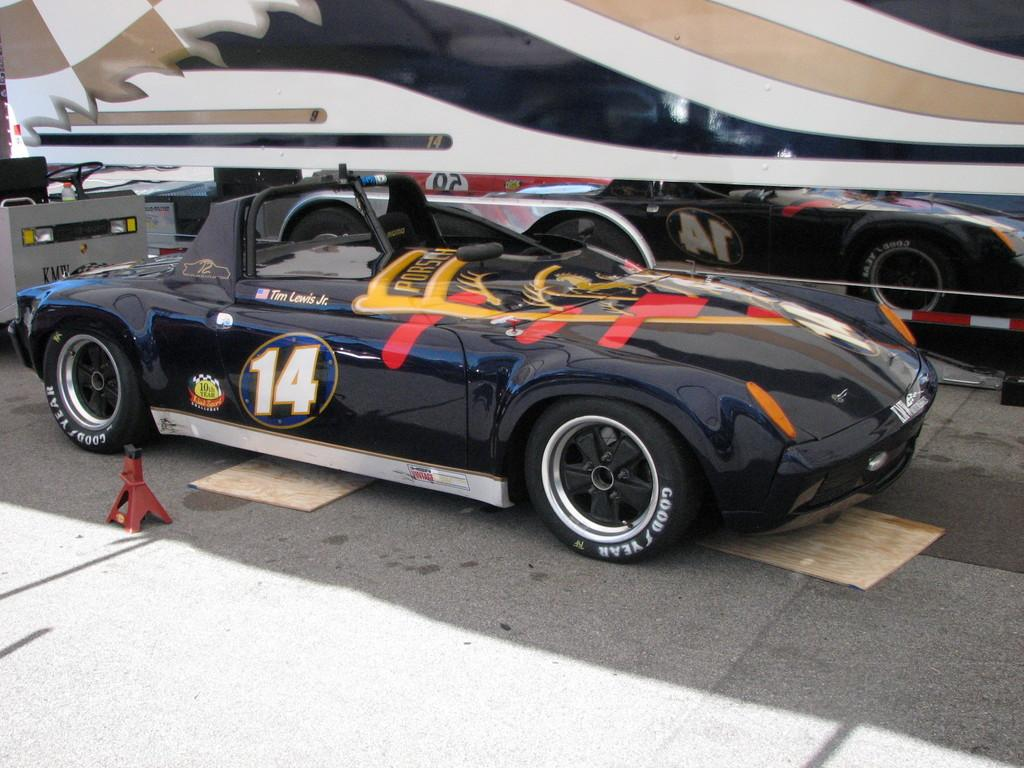<image>
Give a short and clear explanation of the subsequent image. Tim Lewis Jr. drives a black number 14 race car. 